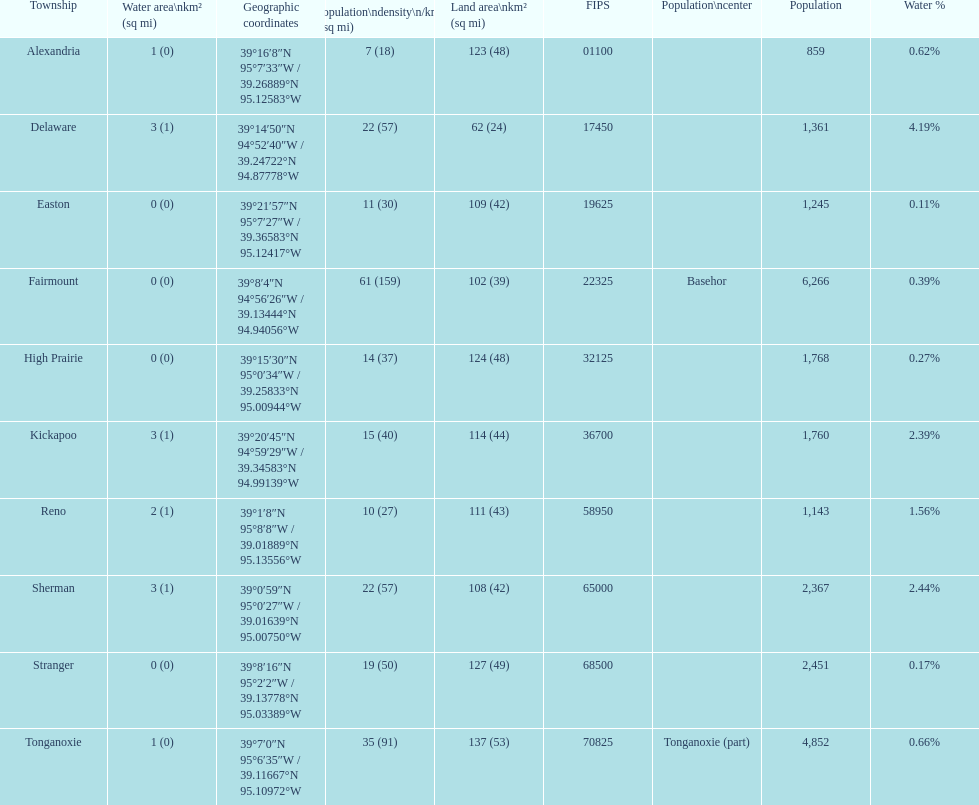Help me parse the entirety of this table. {'header': ['Township', 'Water area\\nkm² (sq\xa0mi)', 'Geographic coordinates', 'Population\\ndensity\\n/km² (/sq\xa0mi)', 'Land area\\nkm² (sq\xa0mi)', 'FIPS', 'Population\\ncenter', 'Population', 'Water\xa0%'], 'rows': [['Alexandria', '1 (0)', '39°16′8″N 95°7′33″W\ufeff / \ufeff39.26889°N 95.12583°W', '7 (18)', '123 (48)', '01100', '', '859', '0.62%'], ['Delaware', '3 (1)', '39°14′50″N 94°52′40″W\ufeff / \ufeff39.24722°N 94.87778°W', '22 (57)', '62 (24)', '17450', '', '1,361', '4.19%'], ['Easton', '0 (0)', '39°21′57″N 95°7′27″W\ufeff / \ufeff39.36583°N 95.12417°W', '11 (30)', '109 (42)', '19625', '', '1,245', '0.11%'], ['Fairmount', '0 (0)', '39°8′4″N 94°56′26″W\ufeff / \ufeff39.13444°N 94.94056°W', '61 (159)', '102 (39)', '22325', 'Basehor', '6,266', '0.39%'], ['High Prairie', '0 (0)', '39°15′30″N 95°0′34″W\ufeff / \ufeff39.25833°N 95.00944°W', '14 (37)', '124 (48)', '32125', '', '1,768', '0.27%'], ['Kickapoo', '3 (1)', '39°20′45″N 94°59′29″W\ufeff / \ufeff39.34583°N 94.99139°W', '15 (40)', '114 (44)', '36700', '', '1,760', '2.39%'], ['Reno', '2 (1)', '39°1′8″N 95°8′8″W\ufeff / \ufeff39.01889°N 95.13556°W', '10 (27)', '111 (43)', '58950', '', '1,143', '1.56%'], ['Sherman', '3 (1)', '39°0′59″N 95°0′27″W\ufeff / \ufeff39.01639°N 95.00750°W', '22 (57)', '108 (42)', '65000', '', '2,367', '2.44%'], ['Stranger', '0 (0)', '39°8′16″N 95°2′2″W\ufeff / \ufeff39.13778°N 95.03389°W', '19 (50)', '127 (49)', '68500', '', '2,451', '0.17%'], ['Tonganoxie', '1 (0)', '39°7′0″N 95°6′35″W\ufeff / \ufeff39.11667°N 95.10972°W', '35 (91)', '137 (53)', '70825', 'Tonganoxie (part)', '4,852', '0.66%']]} How many townships are in leavenworth county? 10. 